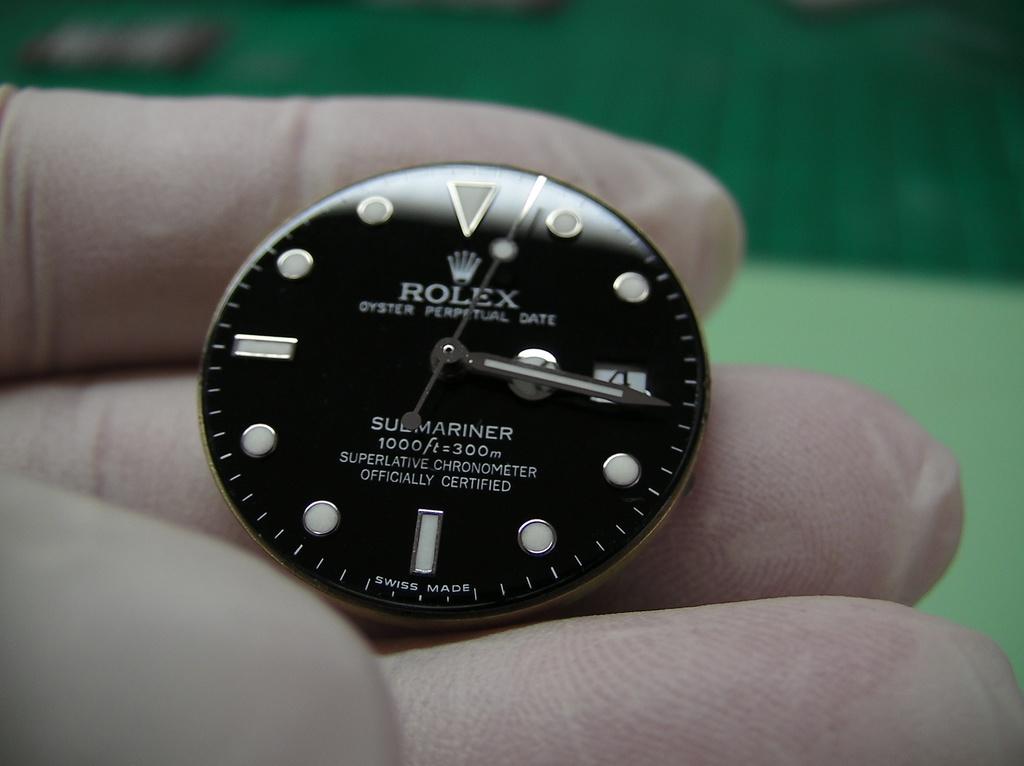What is the brand of this watch?
Make the answer very short. Rolex. What time does the watch say it is?
Keep it short and to the point. 3:16. 